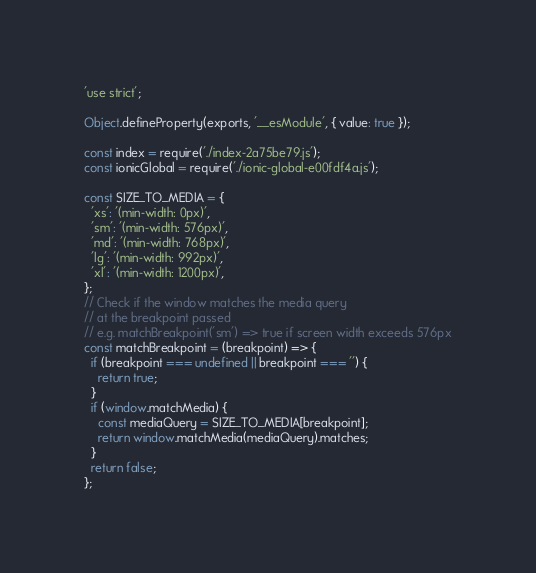Convert code to text. <code><loc_0><loc_0><loc_500><loc_500><_JavaScript_>'use strict';

Object.defineProperty(exports, '__esModule', { value: true });

const index = require('./index-2a75be79.js');
const ionicGlobal = require('./ionic-global-e00fdf4a.js');

const SIZE_TO_MEDIA = {
  'xs': '(min-width: 0px)',
  'sm': '(min-width: 576px)',
  'md': '(min-width: 768px)',
  'lg': '(min-width: 992px)',
  'xl': '(min-width: 1200px)',
};
// Check if the window matches the media query
// at the breakpoint passed
// e.g. matchBreakpoint('sm') => true if screen width exceeds 576px
const matchBreakpoint = (breakpoint) => {
  if (breakpoint === undefined || breakpoint === '') {
    return true;
  }
  if (window.matchMedia) {
    const mediaQuery = SIZE_TO_MEDIA[breakpoint];
    return window.matchMedia(mediaQuery).matches;
  }
  return false;
};
</code> 